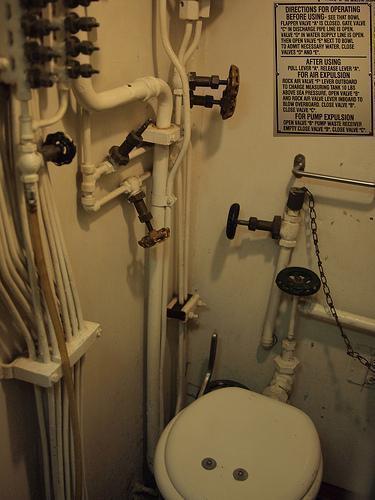How many toilets are there?
Give a very brief answer. 1. 